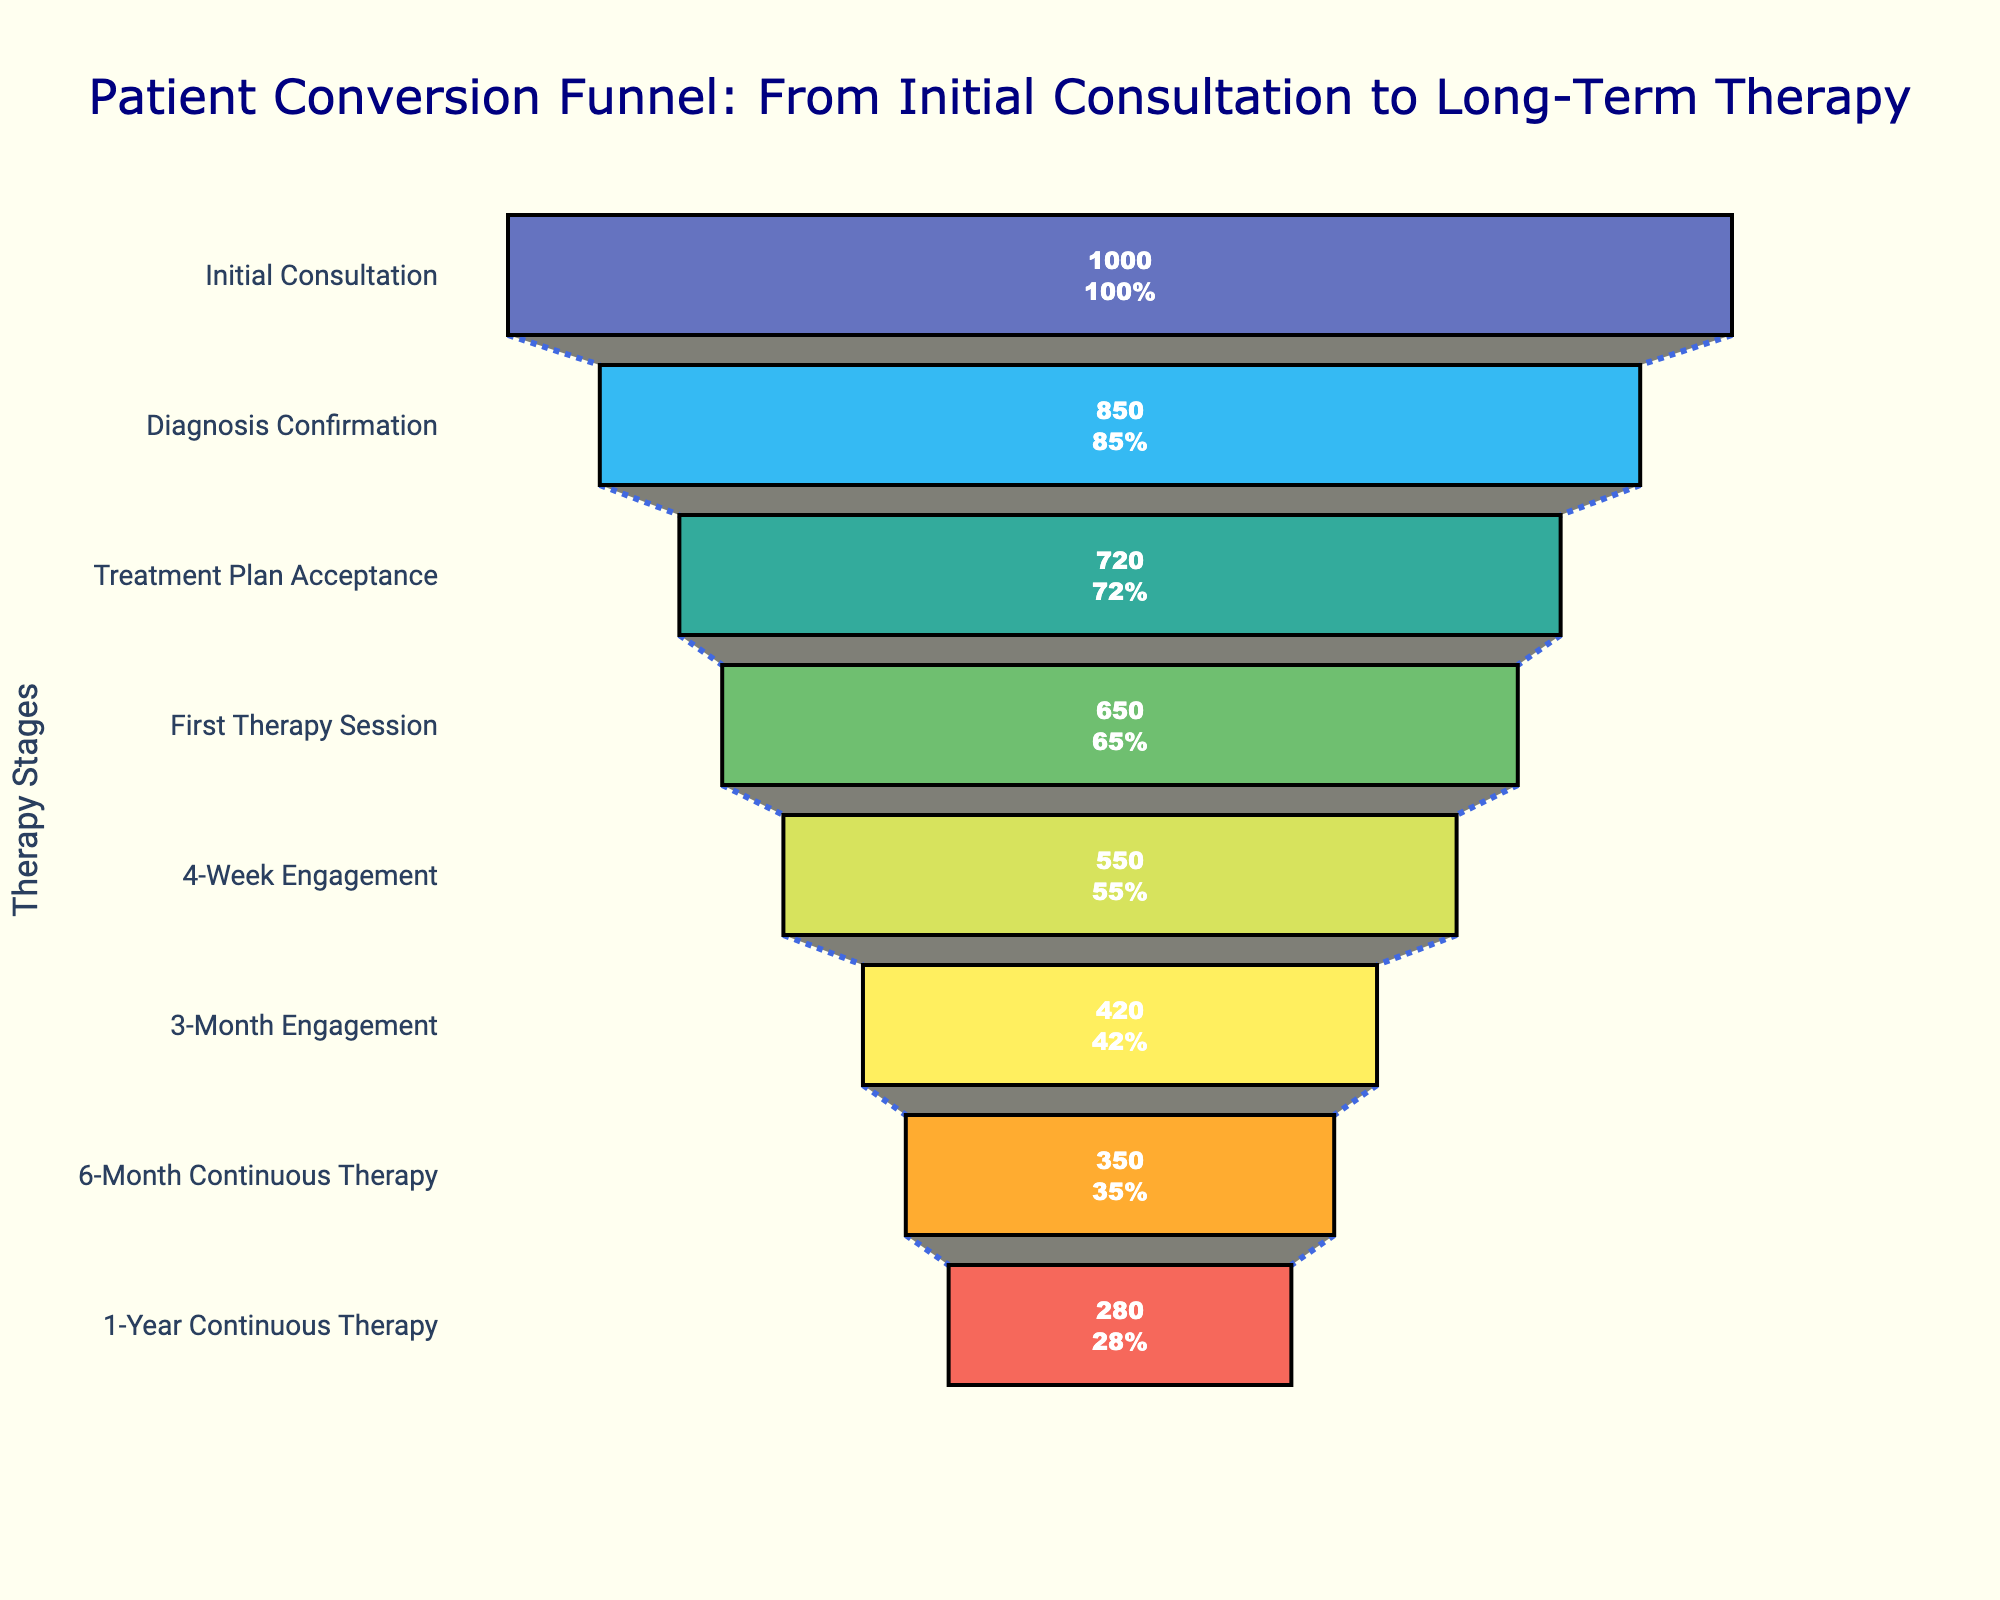What is the title of the funnel chart? The title is displayed prominently at the top of the funnel chart. It is usually in a larger and different colored font for emphasis.
Answer: Patient Conversion Funnel: From Initial Consultation to Long-Term Therapy How many patients remained in continuous therapy for 6 months? The number of patients who remained in continuous therapy for 6 months can be directly read from the funnel stage labeled "6-Month Continuous Therapy."
Answer: 350 What is the conversion rate from the initial consultation to the first therapy session? To find the conversion rate from the initial consultation to the first therapy session, divide the number of patients in the "First Therapy Session" stage by the number of patients in the "Initial Consultation" stage.
Answer: 65% Which stage has the highest drop in the number of patients? To find the stage with the highest drop, observe the funnel chart and identify the stage with the largest reduction in the number of patients from the previous stage.
Answer: Initial Consultation to Diagnosis Confirmation What is the precise conversion rate from initial consultation to 1-year continuous therapy? The conversion rate from initial consultation to 1-year continuous therapy is given in the last stage of the funnel chart.
Answer: 28% How many patients dropped out between the 4-week engagement and the 3-month engagement? To find the number of patients who dropped out, subtract the number of patients in the "3-Month Engagement" stage from the number of patients in the "4-Week Engagement" stage.
Answer: 130 Which stage has the lowest conversion rate? The stage with the lowest conversion rate will have the smallest percentage displayed on the funnel chart.
Answer: 1-Year Continuous Therapy What is the average number of patients in all the stages combined? To find the average number of patients, sum the number of patients in all stages and divide by the total number of stages. (1000 + 850 + 720 + 650 + 550 + 420 + 350 + 280) / 8
Answer: 603.75 Compare the conversion rates between Diagnosis Confirmation and Treatment Plan Acceptance. Which is higher? The conversion rates for both stages are displayed on the chart. Comparing these directly will show which is higher.
Answer: Diagnosis Confirmation What percentage of patients accepted the treatment plan after Diagnosis Confirmation? The conversion rate from Diagnosis Confirmation to Treatment Plan Acceptance can be expressed as a percentage. Divide the number of patients in Treatment Plan Acceptance by Diagnosis Confirmation and multiply by 100. (720 / 850) * 100
Answer: 84.71% 